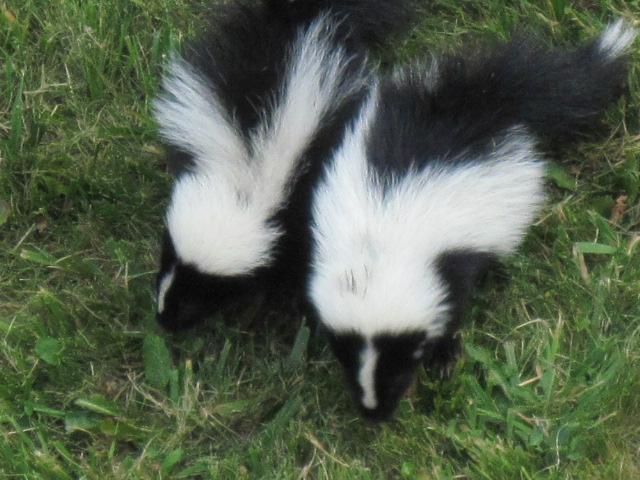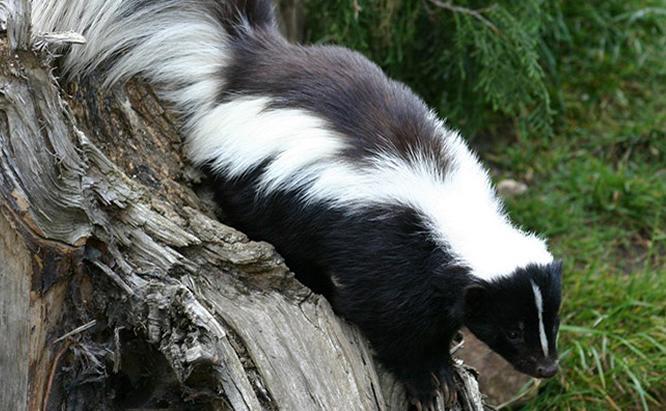The first image is the image on the left, the second image is the image on the right. For the images displayed, is the sentence "One image contains twice as many skunks as the other image." factually correct? Answer yes or no. Yes. 